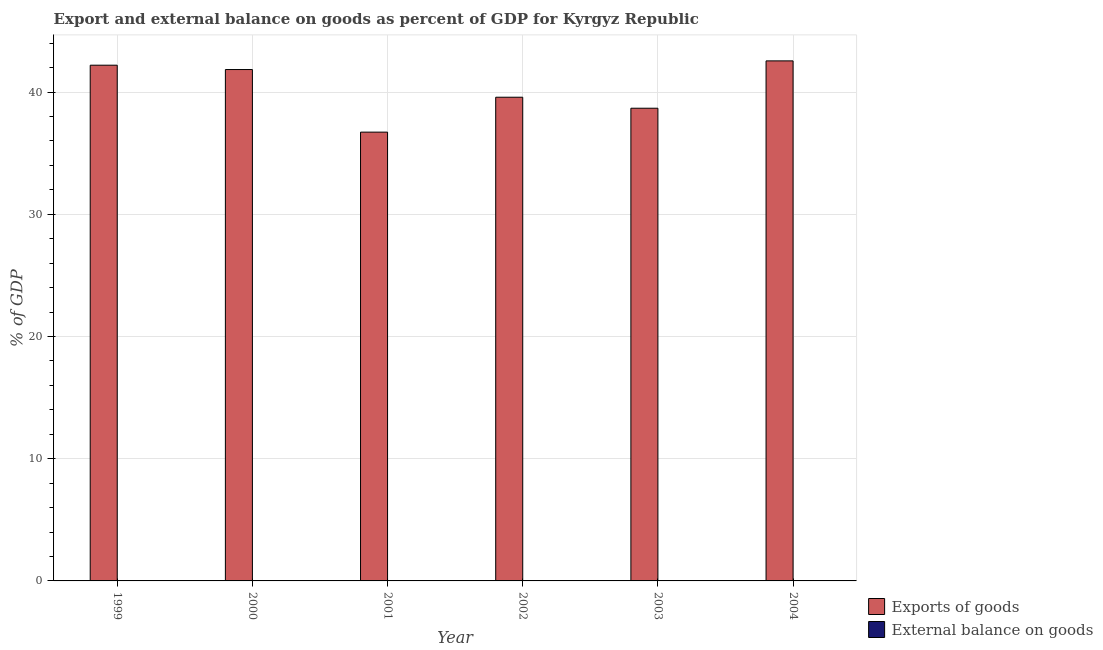How many different coloured bars are there?
Offer a terse response. 1. Are the number of bars per tick equal to the number of legend labels?
Provide a short and direct response. No. What is the label of the 3rd group of bars from the left?
Provide a short and direct response. 2001. In how many cases, is the number of bars for a given year not equal to the number of legend labels?
Your response must be concise. 6. What is the external balance on goods as percentage of gdp in 2001?
Give a very brief answer. 0. Across all years, what is the maximum export of goods as percentage of gdp?
Make the answer very short. 42.56. Across all years, what is the minimum external balance on goods as percentage of gdp?
Keep it short and to the point. 0. What is the total external balance on goods as percentage of gdp in the graph?
Ensure brevity in your answer.  0. What is the difference between the export of goods as percentage of gdp in 1999 and that in 2004?
Your answer should be compact. -0.35. What is the difference between the external balance on goods as percentage of gdp in 2000 and the export of goods as percentage of gdp in 2004?
Offer a terse response. 0. What is the average export of goods as percentage of gdp per year?
Give a very brief answer. 40.27. In the year 1999, what is the difference between the export of goods as percentage of gdp and external balance on goods as percentage of gdp?
Provide a succinct answer. 0. In how many years, is the export of goods as percentage of gdp greater than 24 %?
Ensure brevity in your answer.  6. What is the ratio of the export of goods as percentage of gdp in 1999 to that in 2004?
Your response must be concise. 0.99. Is the export of goods as percentage of gdp in 2001 less than that in 2004?
Provide a short and direct response. Yes. Is the difference between the export of goods as percentage of gdp in 2000 and 2001 greater than the difference between the external balance on goods as percentage of gdp in 2000 and 2001?
Provide a succinct answer. No. What is the difference between the highest and the second highest export of goods as percentage of gdp?
Offer a terse response. 0.35. What is the difference between the highest and the lowest export of goods as percentage of gdp?
Ensure brevity in your answer.  5.83. In how many years, is the external balance on goods as percentage of gdp greater than the average external balance on goods as percentage of gdp taken over all years?
Offer a very short reply. 0. Is the sum of the export of goods as percentage of gdp in 1999 and 2003 greater than the maximum external balance on goods as percentage of gdp across all years?
Give a very brief answer. Yes. What is the difference between two consecutive major ticks on the Y-axis?
Your response must be concise. 10. Are the values on the major ticks of Y-axis written in scientific E-notation?
Ensure brevity in your answer.  No. Does the graph contain any zero values?
Ensure brevity in your answer.  Yes. Where does the legend appear in the graph?
Keep it short and to the point. Bottom right. What is the title of the graph?
Give a very brief answer. Export and external balance on goods as percent of GDP for Kyrgyz Republic. What is the label or title of the X-axis?
Offer a very short reply. Year. What is the label or title of the Y-axis?
Your answer should be compact. % of GDP. What is the % of GDP of Exports of goods in 1999?
Make the answer very short. 42.2. What is the % of GDP of External balance on goods in 1999?
Give a very brief answer. 0. What is the % of GDP in Exports of goods in 2000?
Your response must be concise. 41.85. What is the % of GDP in External balance on goods in 2000?
Your answer should be very brief. 0. What is the % of GDP in Exports of goods in 2001?
Offer a terse response. 36.72. What is the % of GDP in External balance on goods in 2001?
Your answer should be very brief. 0. What is the % of GDP of Exports of goods in 2002?
Offer a very short reply. 39.58. What is the % of GDP in Exports of goods in 2003?
Offer a terse response. 38.68. What is the % of GDP in Exports of goods in 2004?
Give a very brief answer. 42.56. Across all years, what is the maximum % of GDP in Exports of goods?
Provide a short and direct response. 42.56. Across all years, what is the minimum % of GDP in Exports of goods?
Provide a succinct answer. 36.72. What is the total % of GDP of Exports of goods in the graph?
Provide a short and direct response. 241.59. What is the difference between the % of GDP in Exports of goods in 1999 and that in 2000?
Provide a succinct answer. 0.36. What is the difference between the % of GDP of Exports of goods in 1999 and that in 2001?
Your response must be concise. 5.48. What is the difference between the % of GDP in Exports of goods in 1999 and that in 2002?
Your response must be concise. 2.62. What is the difference between the % of GDP of Exports of goods in 1999 and that in 2003?
Your answer should be compact. 3.52. What is the difference between the % of GDP in Exports of goods in 1999 and that in 2004?
Ensure brevity in your answer.  -0.35. What is the difference between the % of GDP in Exports of goods in 2000 and that in 2001?
Make the answer very short. 5.12. What is the difference between the % of GDP of Exports of goods in 2000 and that in 2002?
Your response must be concise. 2.27. What is the difference between the % of GDP in Exports of goods in 2000 and that in 2003?
Your answer should be compact. 3.17. What is the difference between the % of GDP in Exports of goods in 2000 and that in 2004?
Offer a very short reply. -0.71. What is the difference between the % of GDP in Exports of goods in 2001 and that in 2002?
Offer a terse response. -2.86. What is the difference between the % of GDP of Exports of goods in 2001 and that in 2003?
Your answer should be compact. -1.96. What is the difference between the % of GDP of Exports of goods in 2001 and that in 2004?
Provide a short and direct response. -5.83. What is the difference between the % of GDP in Exports of goods in 2002 and that in 2003?
Your answer should be very brief. 0.9. What is the difference between the % of GDP in Exports of goods in 2002 and that in 2004?
Provide a succinct answer. -2.97. What is the difference between the % of GDP of Exports of goods in 2003 and that in 2004?
Offer a terse response. -3.87. What is the average % of GDP in Exports of goods per year?
Keep it short and to the point. 40.27. What is the average % of GDP in External balance on goods per year?
Give a very brief answer. 0. What is the ratio of the % of GDP of Exports of goods in 1999 to that in 2000?
Your answer should be very brief. 1.01. What is the ratio of the % of GDP of Exports of goods in 1999 to that in 2001?
Offer a terse response. 1.15. What is the ratio of the % of GDP of Exports of goods in 1999 to that in 2002?
Give a very brief answer. 1.07. What is the ratio of the % of GDP in Exports of goods in 1999 to that in 2003?
Give a very brief answer. 1.09. What is the ratio of the % of GDP of Exports of goods in 1999 to that in 2004?
Give a very brief answer. 0.99. What is the ratio of the % of GDP of Exports of goods in 2000 to that in 2001?
Your answer should be very brief. 1.14. What is the ratio of the % of GDP of Exports of goods in 2000 to that in 2002?
Ensure brevity in your answer.  1.06. What is the ratio of the % of GDP in Exports of goods in 2000 to that in 2003?
Your answer should be compact. 1.08. What is the ratio of the % of GDP of Exports of goods in 2000 to that in 2004?
Keep it short and to the point. 0.98. What is the ratio of the % of GDP in Exports of goods in 2001 to that in 2002?
Give a very brief answer. 0.93. What is the ratio of the % of GDP of Exports of goods in 2001 to that in 2003?
Give a very brief answer. 0.95. What is the ratio of the % of GDP of Exports of goods in 2001 to that in 2004?
Provide a succinct answer. 0.86. What is the ratio of the % of GDP in Exports of goods in 2002 to that in 2003?
Offer a very short reply. 1.02. What is the ratio of the % of GDP in Exports of goods in 2002 to that in 2004?
Make the answer very short. 0.93. What is the ratio of the % of GDP in Exports of goods in 2003 to that in 2004?
Your answer should be compact. 0.91. What is the difference between the highest and the second highest % of GDP in Exports of goods?
Keep it short and to the point. 0.35. What is the difference between the highest and the lowest % of GDP in Exports of goods?
Offer a very short reply. 5.83. 